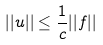Convert formula to latex. <formula><loc_0><loc_0><loc_500><loc_500>| | u | | \leq \frac { 1 } { c } | | f | |</formula> 